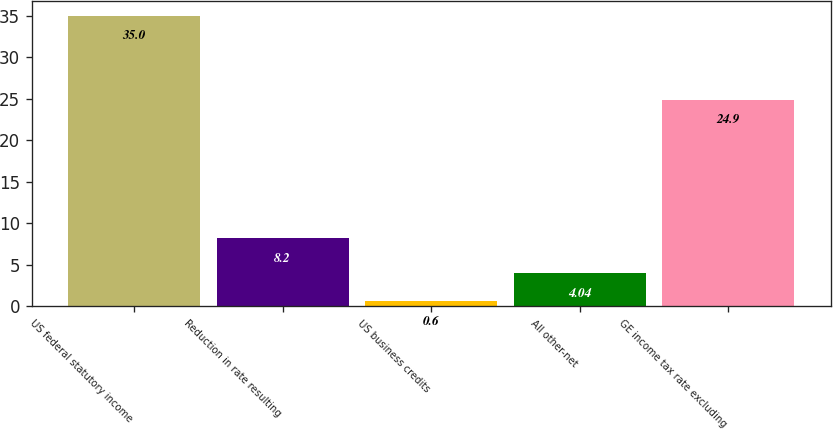Convert chart to OTSL. <chart><loc_0><loc_0><loc_500><loc_500><bar_chart><fcel>US federal statutory income<fcel>Reduction in rate resulting<fcel>US business credits<fcel>All other-net<fcel>GE income tax rate excluding<nl><fcel>35<fcel>8.2<fcel>0.6<fcel>4.04<fcel>24.9<nl></chart> 